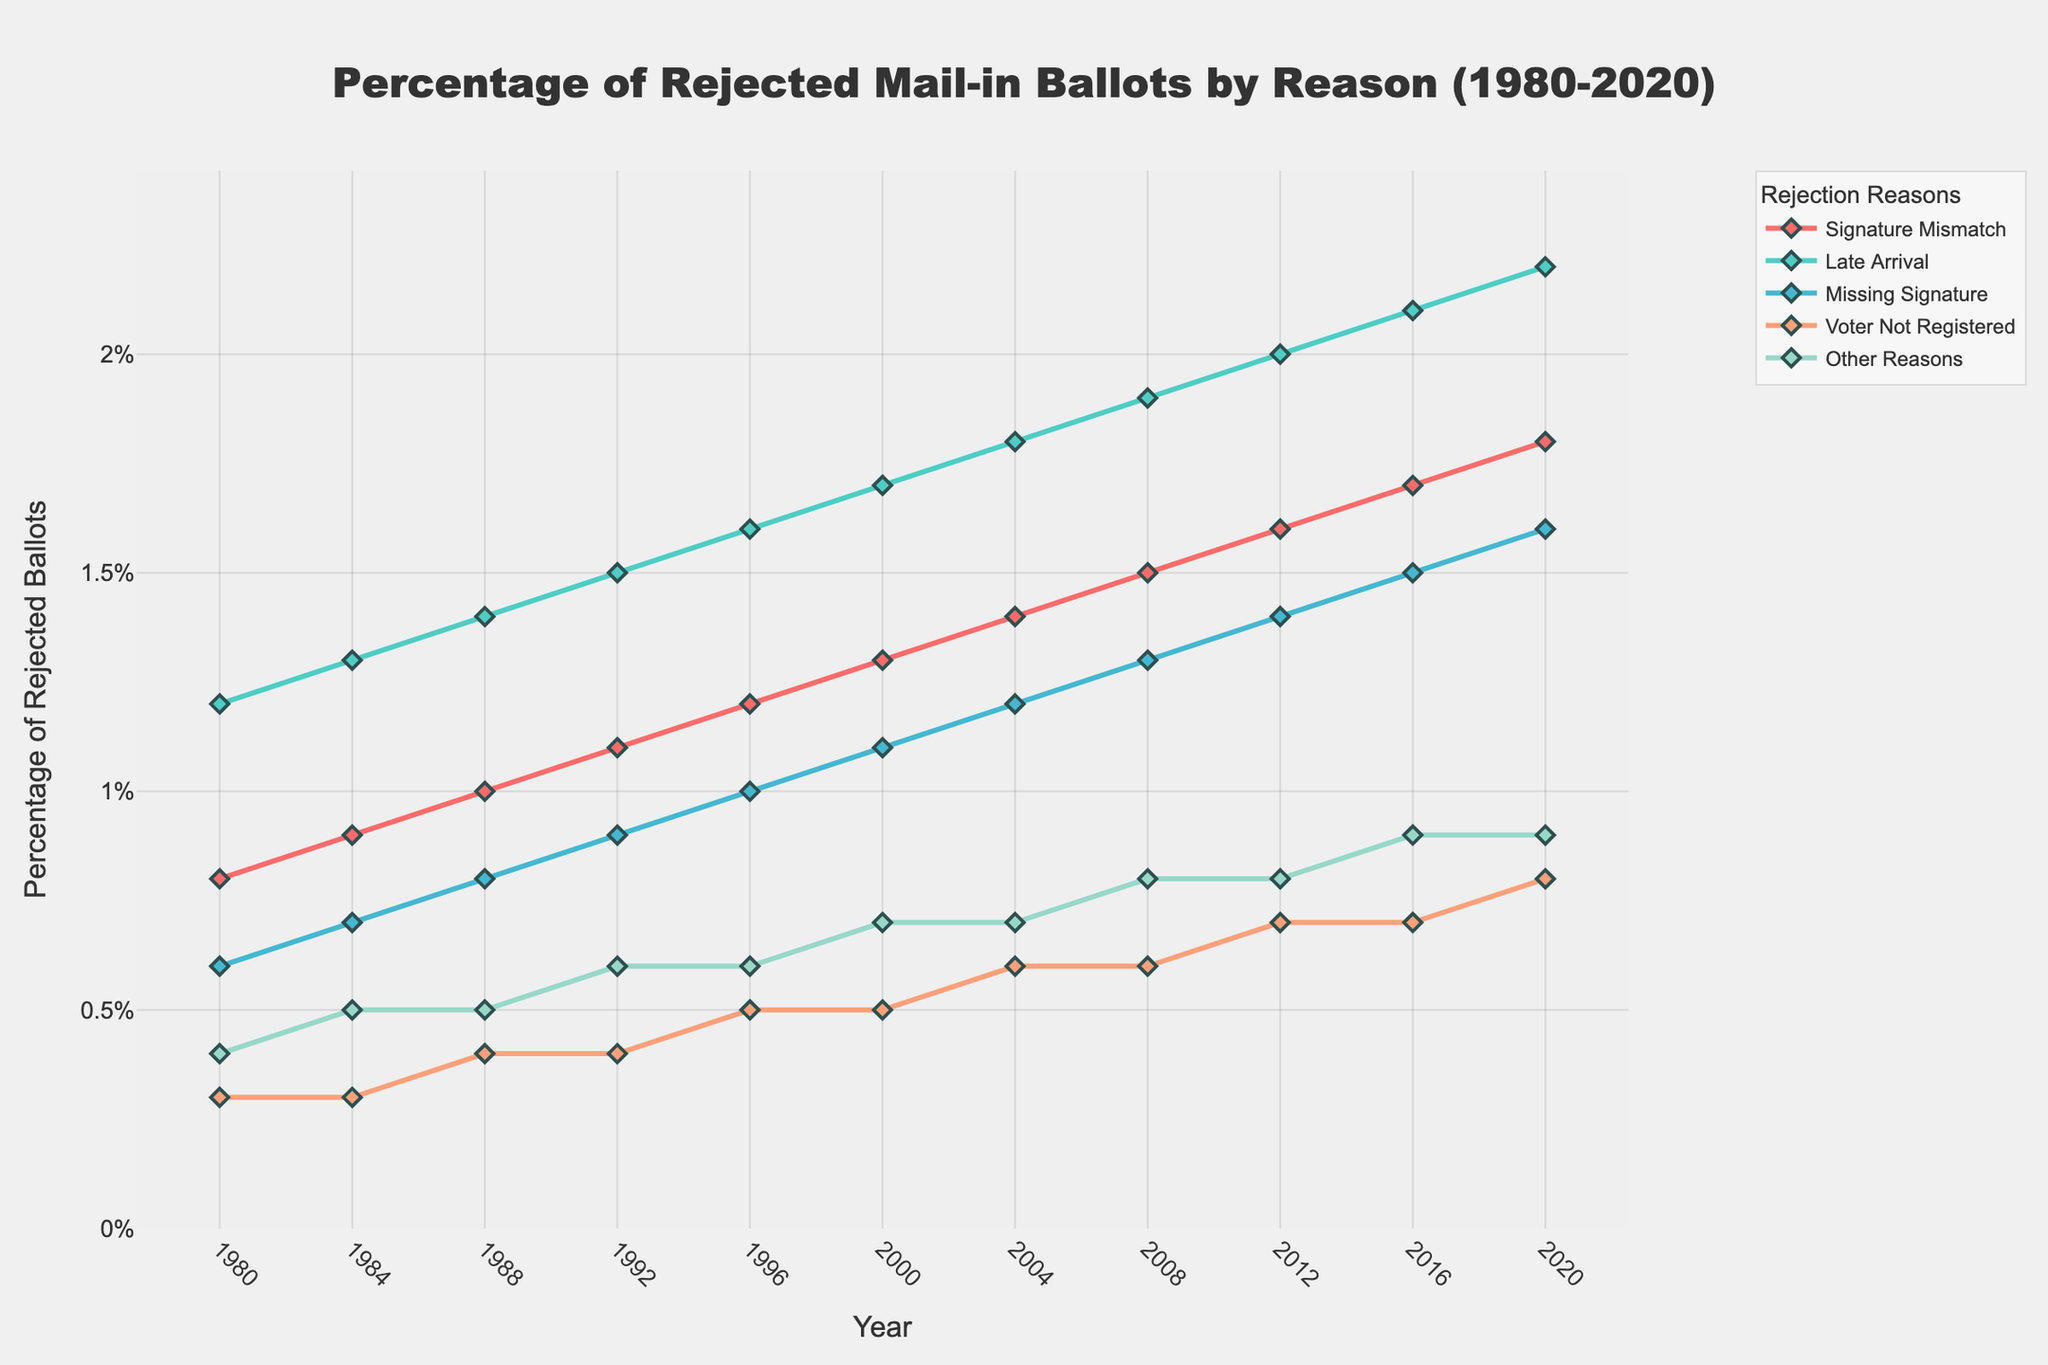What is the overall trend for the percentage of rejected mail-in ballots due to Late Arrival from 1980 to 2020? To find the trend, observe the line representing "Late Arrival." Starting from 1.2% in 1980, it steadily increases by 0.1% every four years until it reaches 2.2% in 2020. Thus, the trend is an increase.
Answer: Increasing Which rejection reason had the highest percentage in 2000? Look at the data points for the year 2000; "Late Arrival" has a percentage of 1.7%, which is higher than any other reason.
Answer: Late Arrival Comparing 1980 and 2020, which rejection reason saw the largest absolute increase in percentage? Calculate the differences for each reason: Signature Mismatch (1.8-0.8=1.0%), Late Arrival (2.2-1.2=1.0%), Missing Signature (1.6-0.6=1.0%), Voter Not Registered (0.8-0.3=0.5%), Other Reasons (0.9-0.4=0.5%). The largest increase is tied for Signature Mismatch, Late Arrival, and Missing Signature, all increased by 1.0%.
Answer: Signature Mismatch, Late Arrival, Missing Signature What is the average percentage of rejected mail-in ballots due to Missing Signature over the four election years from 2008 to 2020? Sum the percentages over those years: 1.3% + 1.4% + 1.5% + 1.6% = 5.8%. There are four years, so the average is 5.8% / 4 = 1.45%.
Answer: 1.45% Which two reasons for rejection see a similar pattern in their trends from 1980 to 2020? Observe the lines for each reason. Both "Signature Mismatch" and "Late Arrival" show a steadily increasing trend, rising by 0.1% in almost every election year.
Answer: Signature Mismatch and Late Arrival What is the percentage difference between Signature Mismatch and Other Reasons in 2012? Find the percentages for 2012: Signature Mismatch is 1.6% and Other Reasons are 0.8%. The difference is 1.6% - 0.8% = 0.8%.
Answer: 0.8% From 1980 to 2000, which reason for rejection showed the slowest rate of increase? Compare the percentage increases for each reason: Signature Mismatch (1.3-0.8=0.5%), Late Arrival (1.7-1.2=0.5%), Missing Signature (1.1-0.6=0.5%), Voter Not Registered (0.5-0.3=0.2%), Other Reasons (0.7-0.4=0.3%). The slowest rate of increase is for "Voter Not Registered."
Answer: Voter Not Registered Describe the visual difference between the trends in "Voter Not Registered" and "Late Arrival." "Voter Not Registered" shows a relatively flat trend, slowly increasing from 0.3% to 0.8%. Meanwhile, "Late Arrival" has a steep, consistent rise across all years, visually indicated by a steeper and consistently upwards-sloping line.
Answer: Voter Not Registered is flatter; Late Arrival is steeper In which election year did the "Missing Signature" rejection reason first surpass 1.0%? Identify the point on the "Missing Signature" line where it crosses 1.0%. This occurs in 1996, where it rises to 1.0%.
Answer: 1996 How does the trend for "Other Reasons" from 1980 to 2000 compare to that from 2000 to 2020? The trend's for 1980 to 2000 increased slowly from 0.4% to 0.7%, and 2000 to 2020 increased similarly gradually from 0.7% to 0.9%. The overall rate of increase is consistent but slightly slower after 2000.
Answer: Slightly slower after 2000 